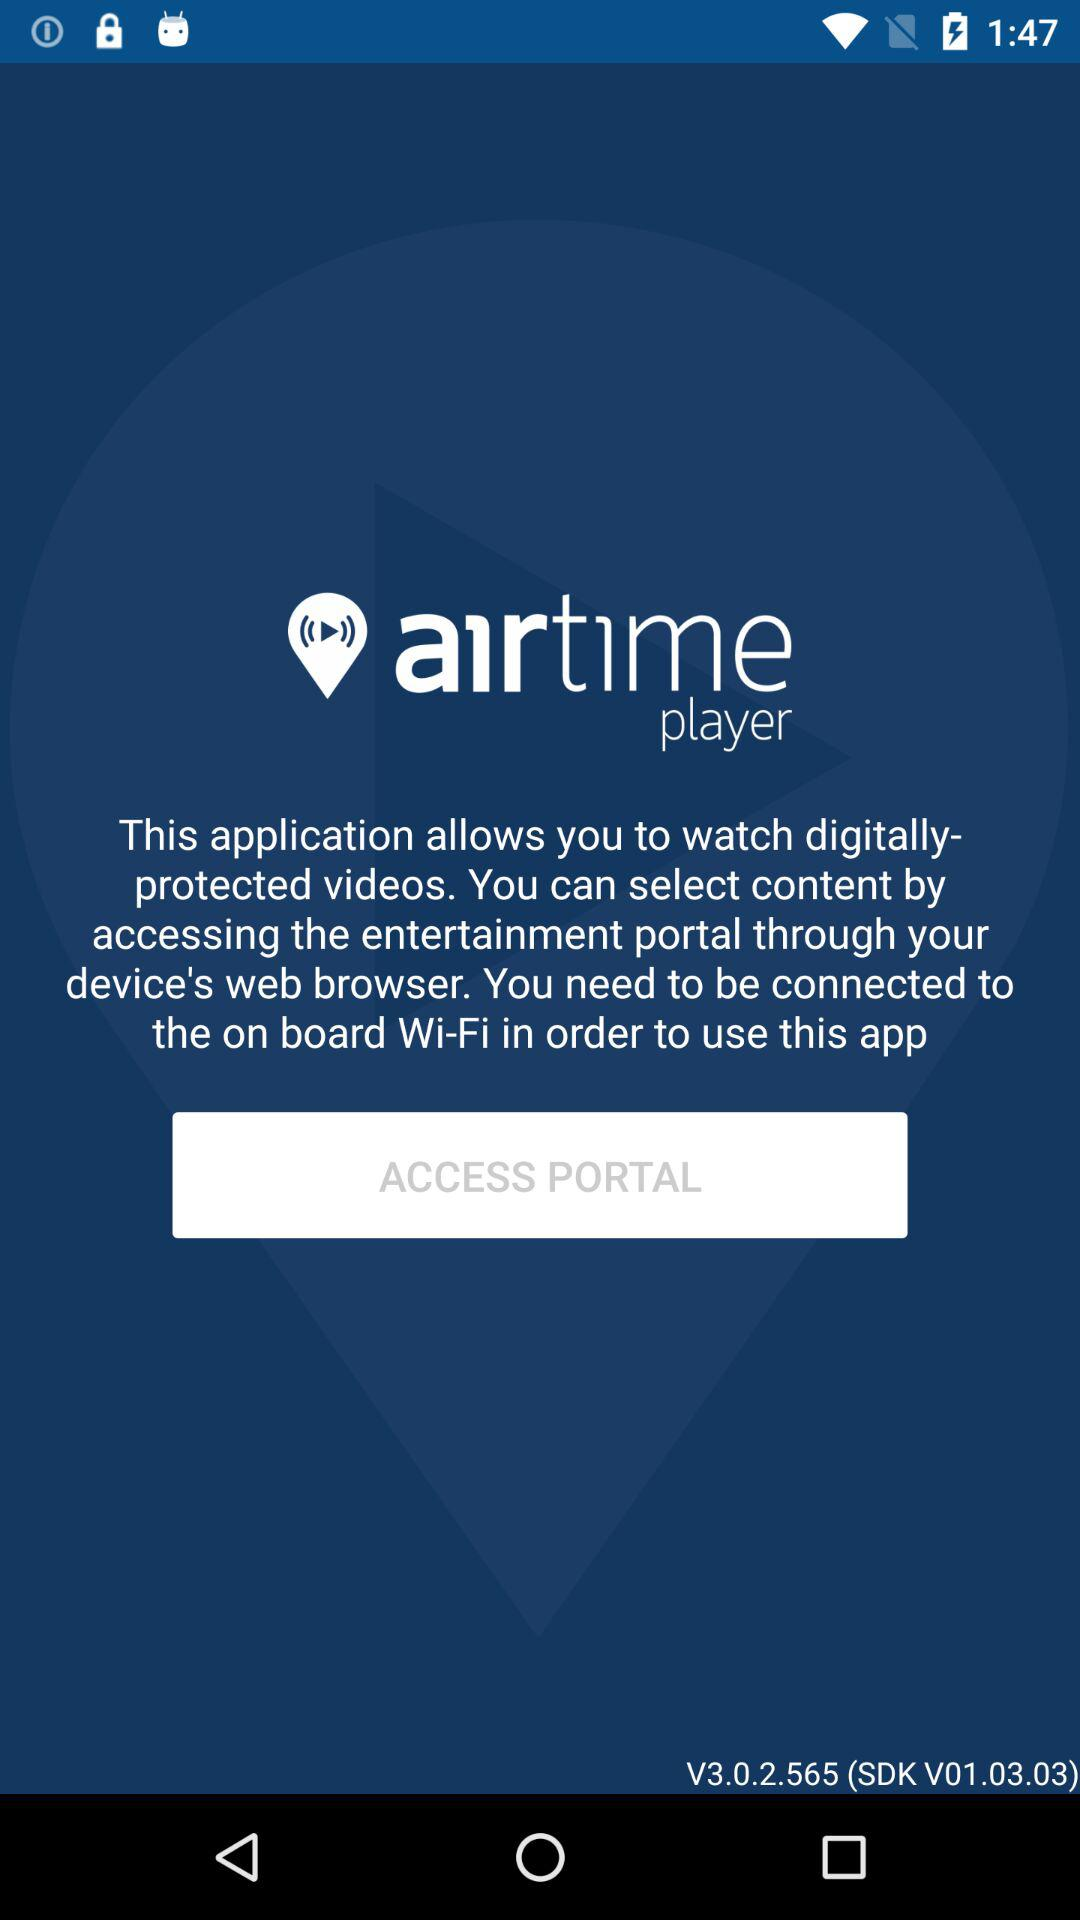When was version 3.0.2.565 updated?
When the provided information is insufficient, respond with <no answer>. <no answer> 